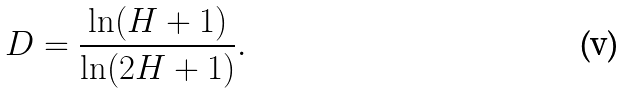Convert formula to latex. <formula><loc_0><loc_0><loc_500><loc_500>D = \frac { \ln ( H + 1 ) } { \ln ( 2 H + 1 ) } .</formula> 